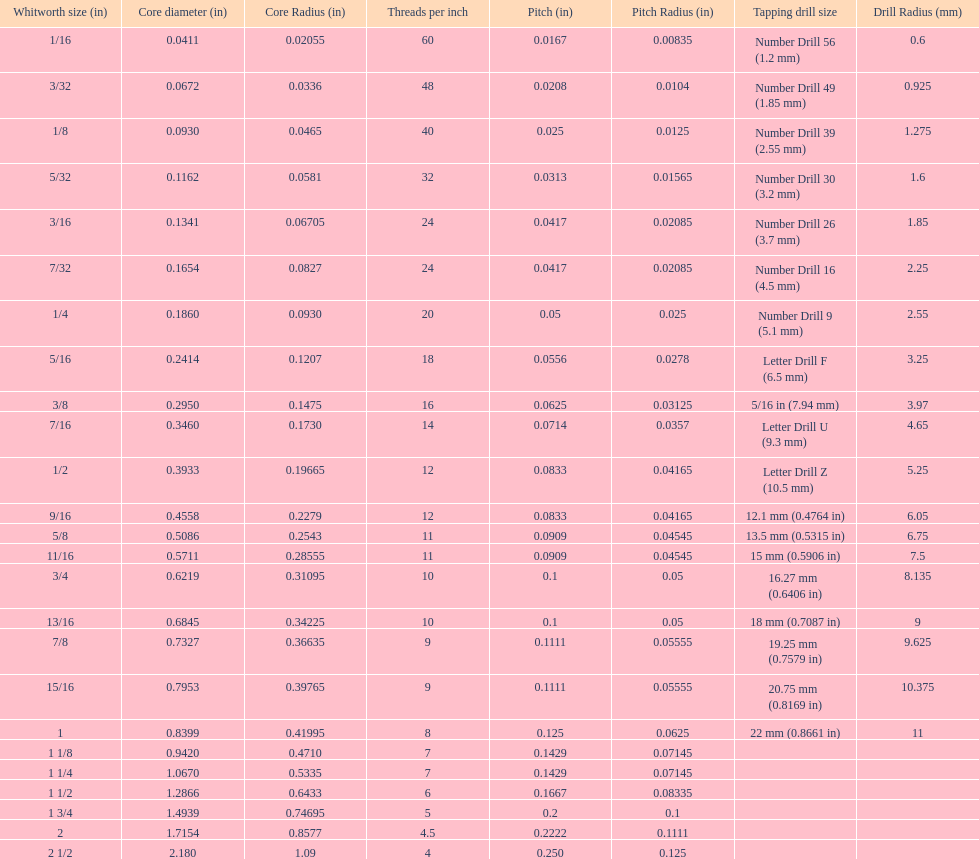Does any whitworth size have the same core diameter as the number drill 26? 3/16. 